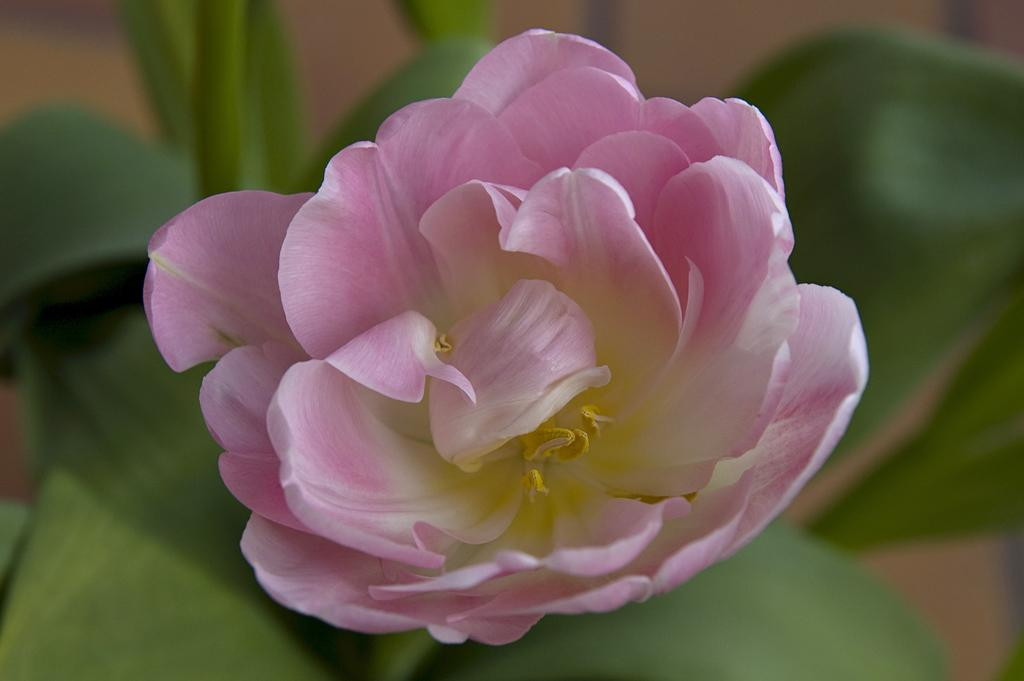What type of plant can be seen in the image? There is a flower in the image. What else is present on the plant besides the flower? There are leaves in the image. Can you describe the background of the image? The background of the image is blurred. What type of teaching method is being demonstrated through the window in the image? There is no window or teaching method present in the image; it features a flower and leaves with a blurred background. 